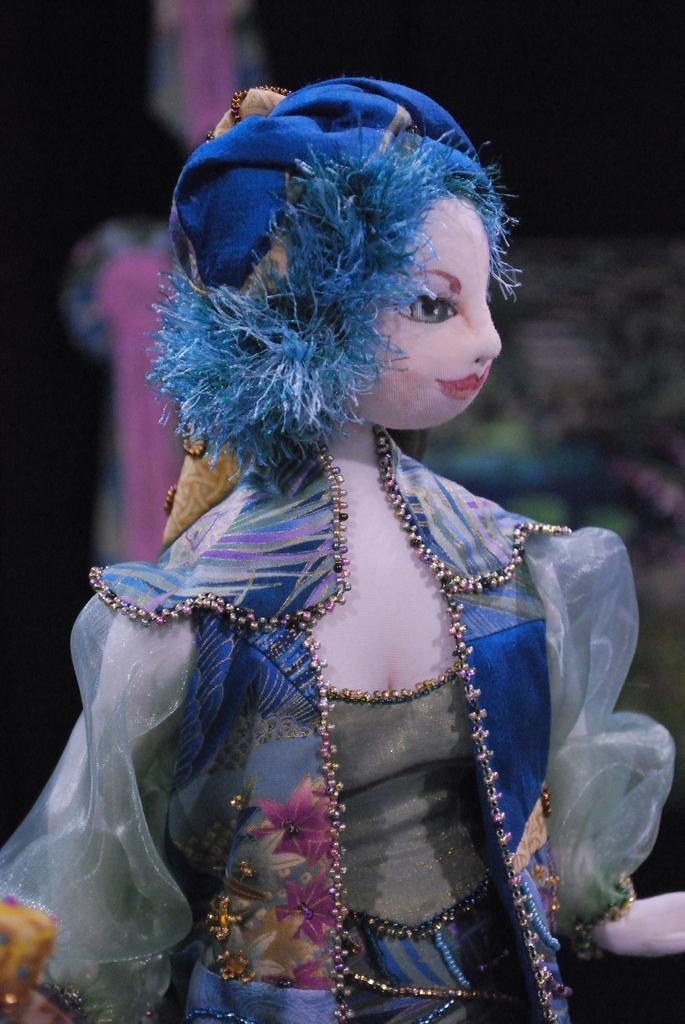In one or two sentences, can you explain what this image depicts? In the foreground of the image there is a doll. The background of the image is blur. 